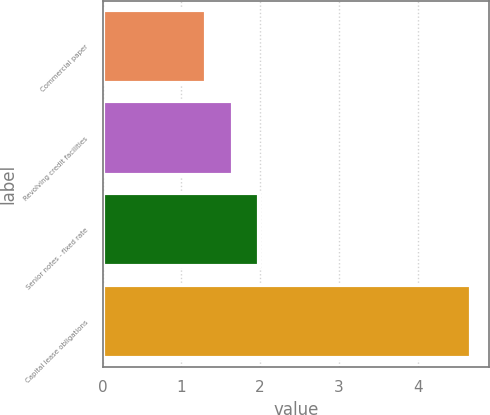Convert chart. <chart><loc_0><loc_0><loc_500><loc_500><bar_chart><fcel>Commercial paper<fcel>Revolving credit facilities<fcel>Senior notes - fixed rate<fcel>Capital lease obligations<nl><fcel>1.31<fcel>1.65<fcel>1.99<fcel>4.67<nl></chart> 